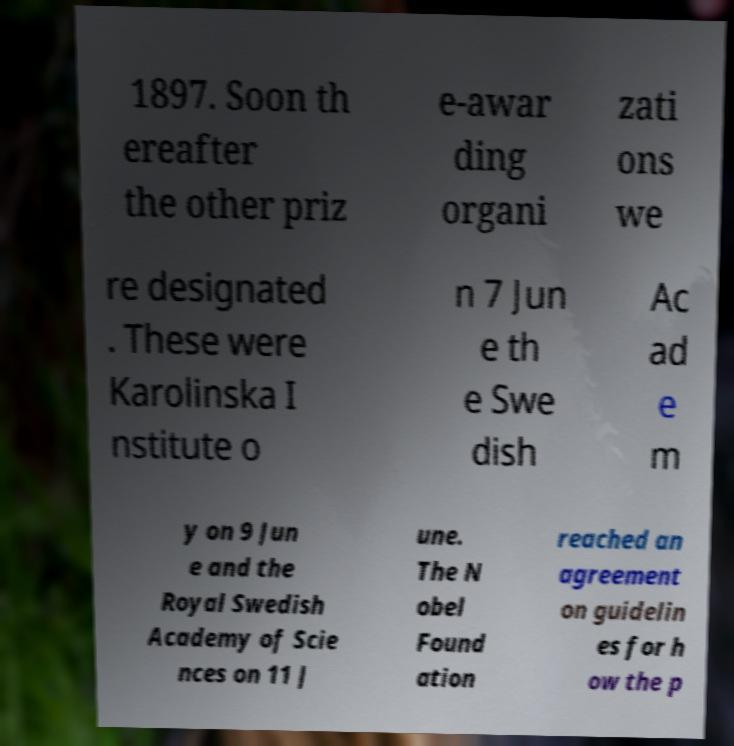Could you extract and type out the text from this image? 1897. Soon th ereafter the other priz e-awar ding organi zati ons we re designated . These were Karolinska I nstitute o n 7 Jun e th e Swe dish Ac ad e m y on 9 Jun e and the Royal Swedish Academy of Scie nces on 11 J une. The N obel Found ation reached an agreement on guidelin es for h ow the p 